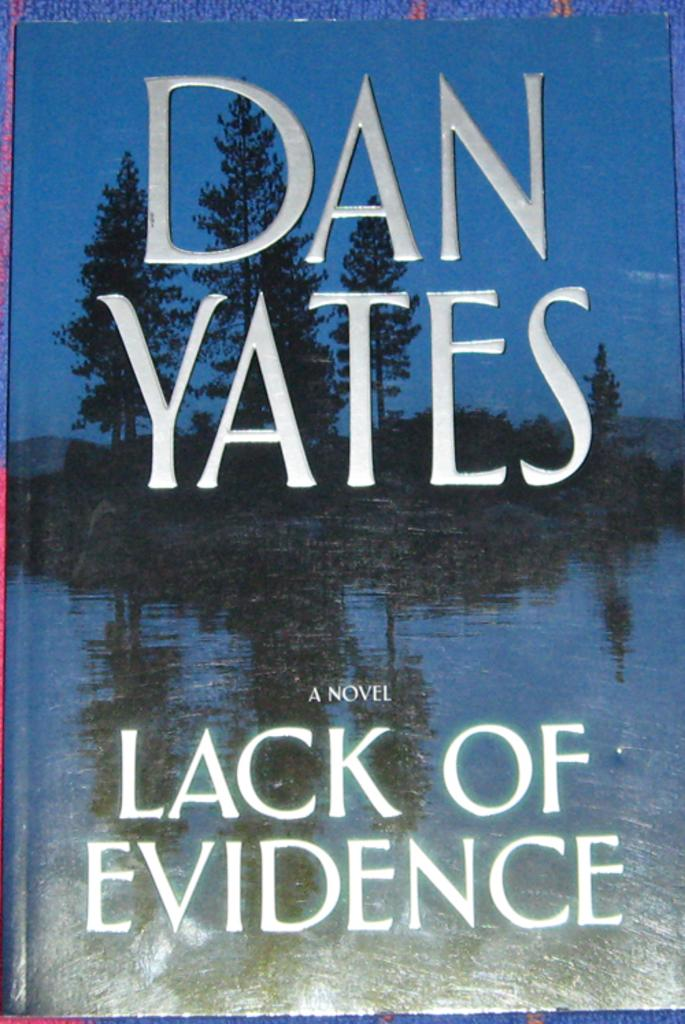<image>
Present a compact description of the photo's key features. A book titled Lack of Evidence by Dan Yates. 